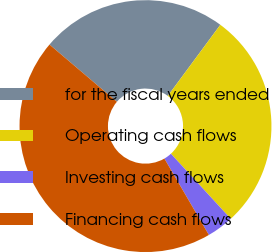Convert chart. <chart><loc_0><loc_0><loc_500><loc_500><pie_chart><fcel>for the fiscal years ended<fcel>Operating cash flows<fcel>Investing cash flows<fcel>Financing cash flows<nl><fcel>23.92%<fcel>28.04%<fcel>3.44%<fcel>44.6%<nl></chart> 